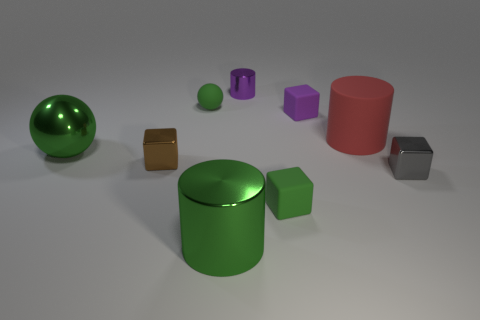Is the color of the big cylinder that is on the left side of the small metallic cylinder the same as the tiny matte sphere?
Give a very brief answer. Yes. The purple cube is what size?
Ensure brevity in your answer.  Small. What material is the brown block that is the same size as the purple metal cylinder?
Keep it short and to the point. Metal. What color is the cylinder on the left side of the purple cylinder?
Your response must be concise. Green. What number of big red matte cylinders are there?
Offer a terse response. 1. Are there any tiny shiny blocks left of the green matte object that is left of the metal cylinder that is in front of the big metallic ball?
Ensure brevity in your answer.  Yes. The purple metal object that is the same size as the green rubber cube is what shape?
Provide a succinct answer. Cylinder. How many other objects are there of the same color as the large metallic ball?
Offer a very short reply. 3. What material is the large red object?
Your answer should be compact. Rubber. What number of other things are made of the same material as the green block?
Your answer should be very brief. 3. 